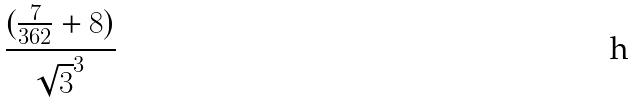Convert formula to latex. <formula><loc_0><loc_0><loc_500><loc_500>\frac { ( \frac { 7 } { 3 6 2 } + 8 ) } { \sqrt { 3 } ^ { 3 } }</formula> 